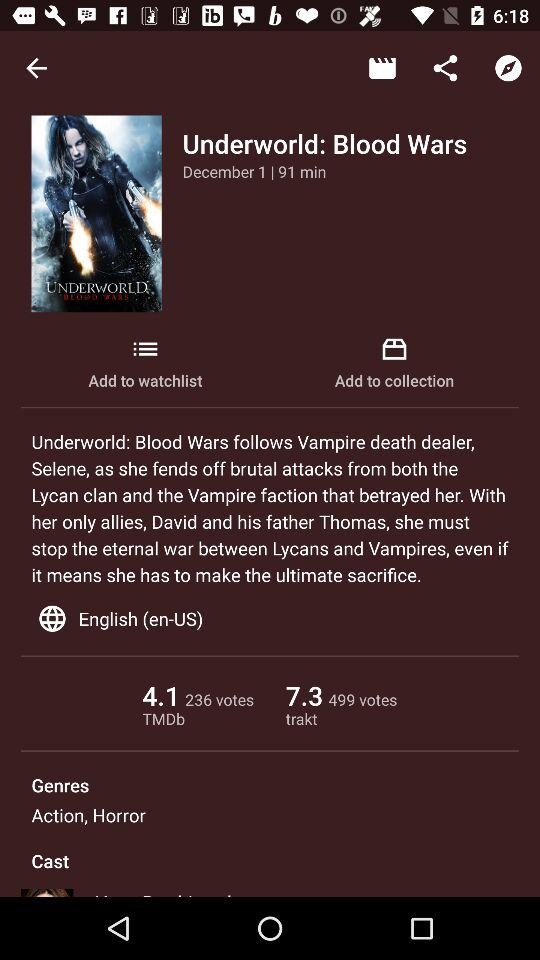What is the TMDB rating? The TMDB rating is 4.1. 